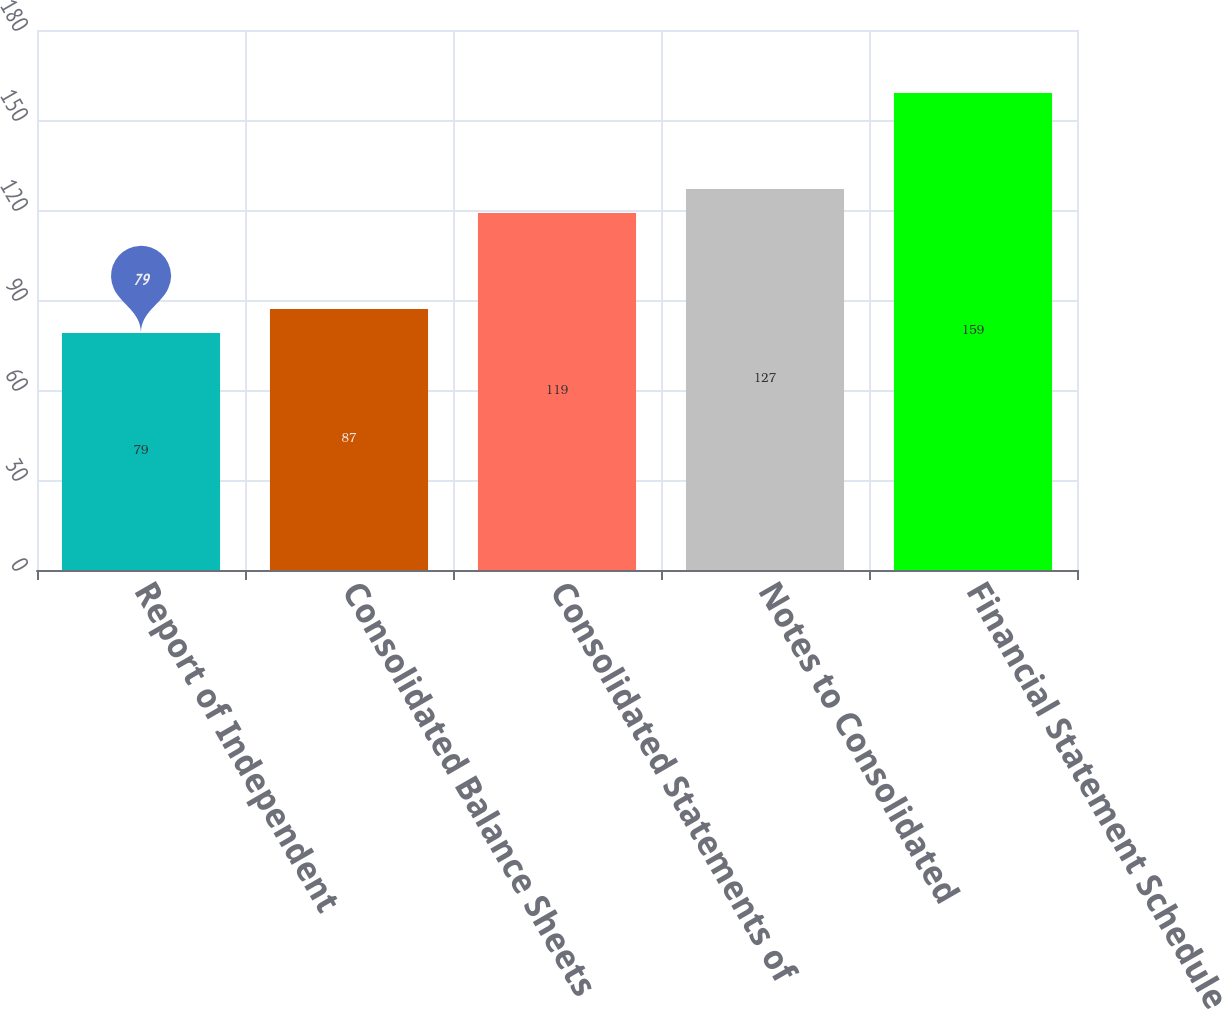Convert chart to OTSL. <chart><loc_0><loc_0><loc_500><loc_500><bar_chart><fcel>Report of Independent<fcel>Consolidated Balance Sheets<fcel>Consolidated Statements of<fcel>Notes to Consolidated<fcel>Financial Statement Schedule<nl><fcel>79<fcel>87<fcel>119<fcel>127<fcel>159<nl></chart> 